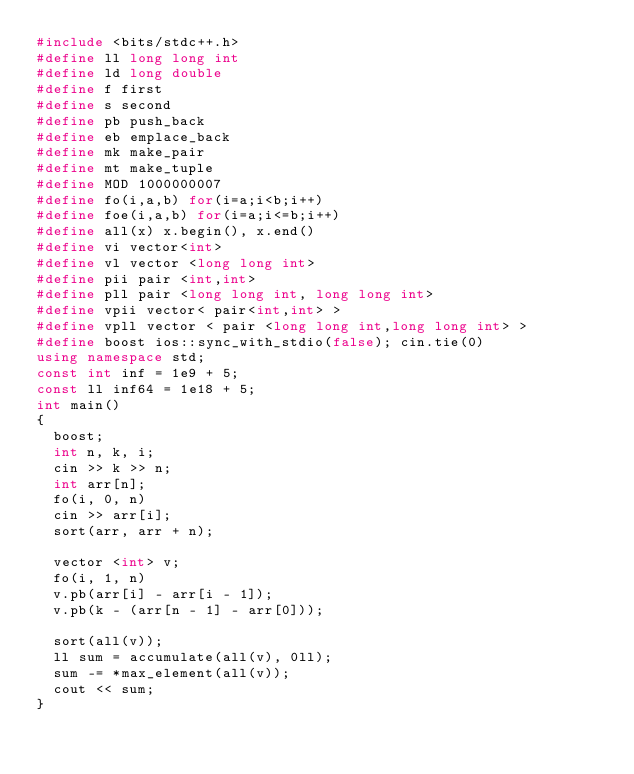Convert code to text. <code><loc_0><loc_0><loc_500><loc_500><_C++_>#include <bits/stdc++.h>
#define ll long long int
#define ld long double
#define f first
#define s second
#define pb push_back
#define eb emplace_back
#define mk make_pair
#define mt make_tuple
#define MOD 1000000007
#define fo(i,a,b) for(i=a;i<b;i++)
#define foe(i,a,b) for(i=a;i<=b;i++)
#define all(x) x.begin(), x.end()
#define vi vector<int>
#define vl vector <long long int>
#define pii pair <int,int>
#define pll pair <long long int, long long int>
#define vpii vector< pair<int,int> >
#define vpll vector < pair <long long int,long long int> >
#define boost ios::sync_with_stdio(false); cin.tie(0)
using namespace std;
const int inf = 1e9 + 5;
const ll inf64 = 1e18 + 5;
int main()
{
	boost;
	int n, k, i;
	cin >> k >> n;
	int arr[n];
	fo(i, 0, n)
	cin >> arr[i];
	sort(arr, arr + n);
	
	vector <int> v;
	fo(i, 1, n)
	v.pb(arr[i] - arr[i - 1]);
	v.pb(k - (arr[n - 1] - arr[0]));
	
	sort(all(v));
	ll sum = accumulate(all(v), 0ll);
	sum -= *max_element(all(v));
	cout << sum;
}
</code> 